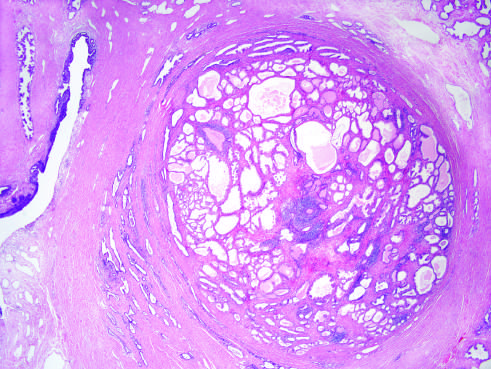what is caused predominantly by stromal, rather than glandular, proliferation in other cases of nodular hyperplasia?
Answer the question using a single word or phrase. The nodularity 